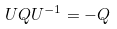<formula> <loc_0><loc_0><loc_500><loc_500>U Q U ^ { - 1 } = - Q</formula> 